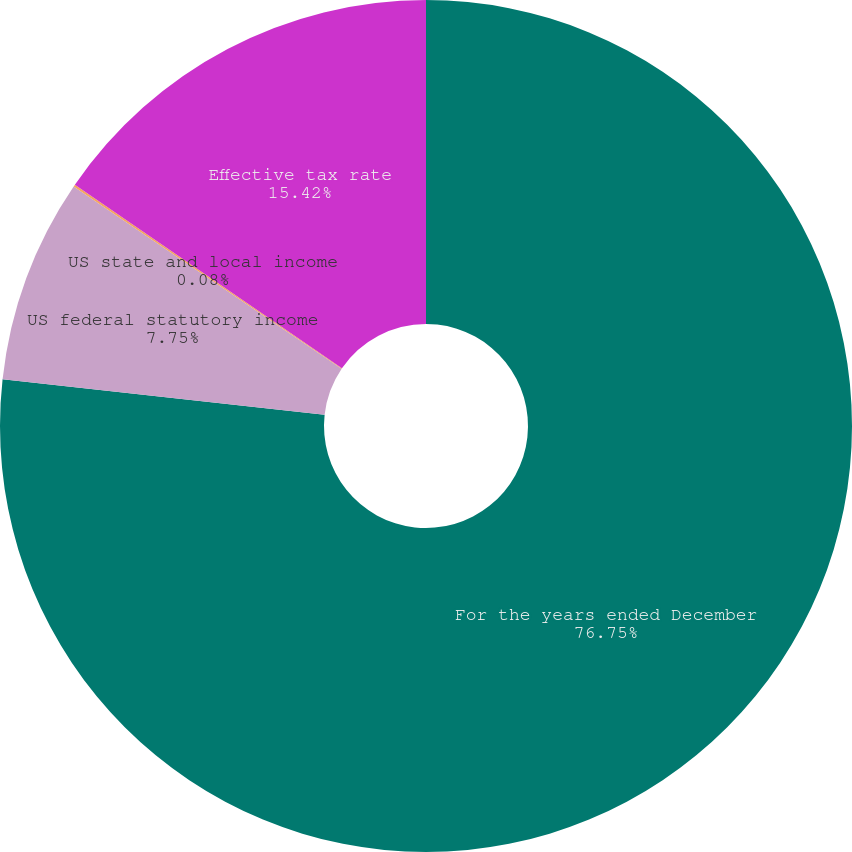Convert chart to OTSL. <chart><loc_0><loc_0><loc_500><loc_500><pie_chart><fcel>For the years ended December<fcel>US federal statutory income<fcel>US state and local income<fcel>Effective tax rate<nl><fcel>76.75%<fcel>7.75%<fcel>0.08%<fcel>15.42%<nl></chart> 